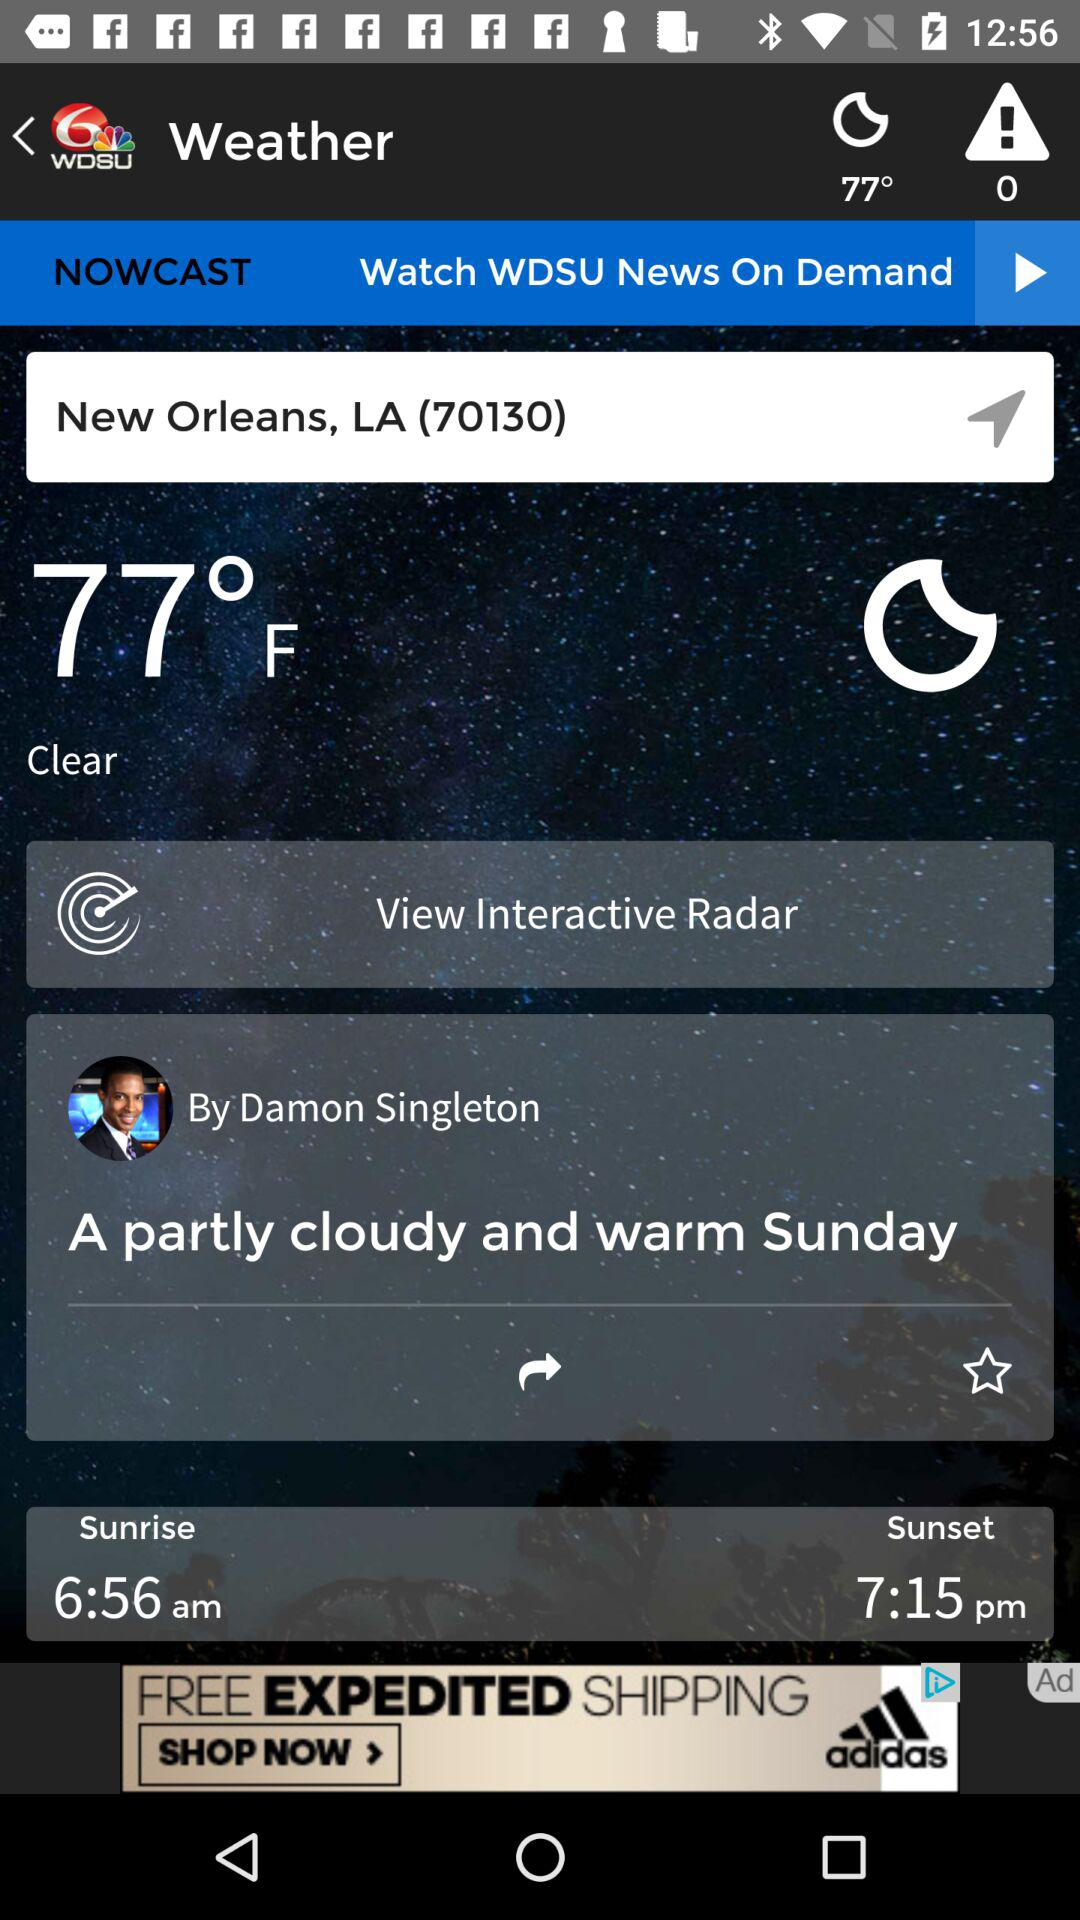Which place's temperature is shown on the screen? The place is New Orleans, LA (70130). 